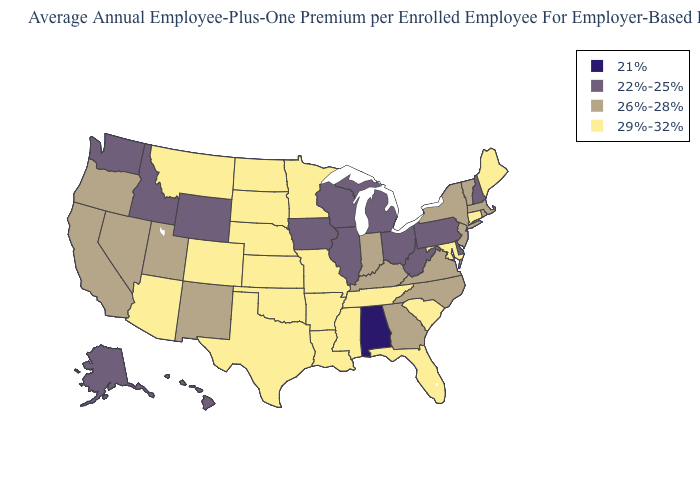Name the states that have a value in the range 26%-28%?
Give a very brief answer. California, Georgia, Indiana, Kentucky, Massachusetts, Nevada, New Jersey, New Mexico, New York, North Carolina, Oregon, Rhode Island, Utah, Vermont, Virginia. What is the value of Pennsylvania?
Give a very brief answer. 22%-25%. What is the value of Arizona?
Write a very short answer. 29%-32%. Among the states that border Louisiana , which have the lowest value?
Quick response, please. Arkansas, Mississippi, Texas. Does Kentucky have a higher value than New Hampshire?
Be succinct. Yes. Does Illinois have the lowest value in the USA?
Give a very brief answer. No. How many symbols are there in the legend?
Answer briefly. 4. What is the lowest value in the Northeast?
Quick response, please. 22%-25%. Name the states that have a value in the range 22%-25%?
Write a very short answer. Alaska, Delaware, Hawaii, Idaho, Illinois, Iowa, Michigan, New Hampshire, Ohio, Pennsylvania, Washington, West Virginia, Wisconsin, Wyoming. Which states have the lowest value in the West?
Be succinct. Alaska, Hawaii, Idaho, Washington, Wyoming. What is the value of Indiana?
Answer briefly. 26%-28%. Does Pennsylvania have the same value as New Hampshire?
Write a very short answer. Yes. Does Idaho have a lower value than California?
Short answer required. Yes. Which states have the highest value in the USA?
Write a very short answer. Arizona, Arkansas, Colorado, Connecticut, Florida, Kansas, Louisiana, Maine, Maryland, Minnesota, Mississippi, Missouri, Montana, Nebraska, North Dakota, Oklahoma, South Carolina, South Dakota, Tennessee, Texas. What is the lowest value in states that border Ohio?
Short answer required. 22%-25%. 